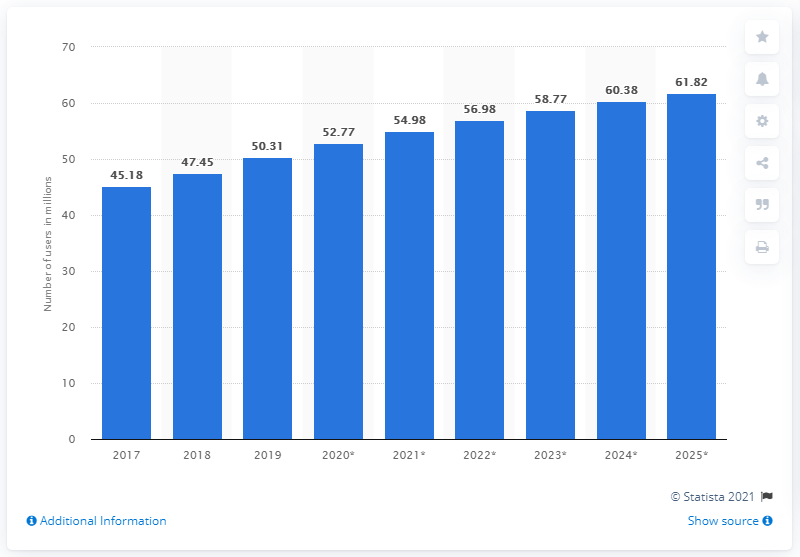Give some essential details in this illustration. Since 2017, the number of internet users in Thailand has been increasing. In 2019, approximately 50.31% of the population in Thailand had access to the internet. 